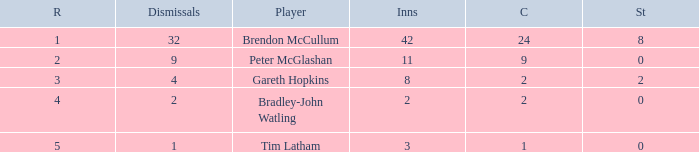How many dismissals did the player Peter McGlashan have? 9.0. 